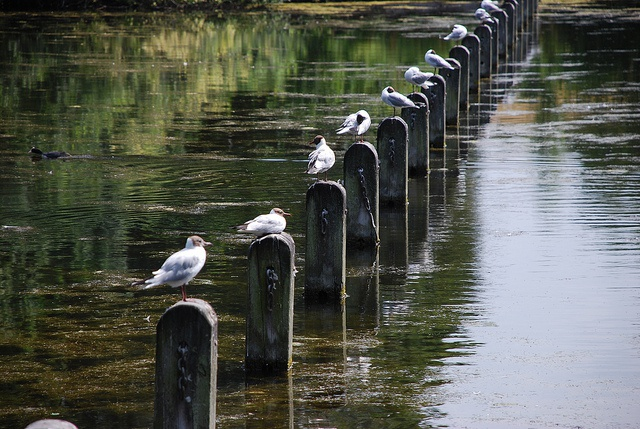Describe the objects in this image and their specific colors. I can see bird in black, lavender, darkgray, and gray tones, bird in black, white, gray, and darkgray tones, bird in black, white, darkgray, and gray tones, bird in black, white, gray, and darkgray tones, and bird in black, lavender, gray, and navy tones in this image. 